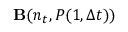Convert formula to latex. <formula><loc_0><loc_0><loc_500><loc_500>{ B } ( n _ { t } , P ( 1 , \Delta t ) )</formula> 